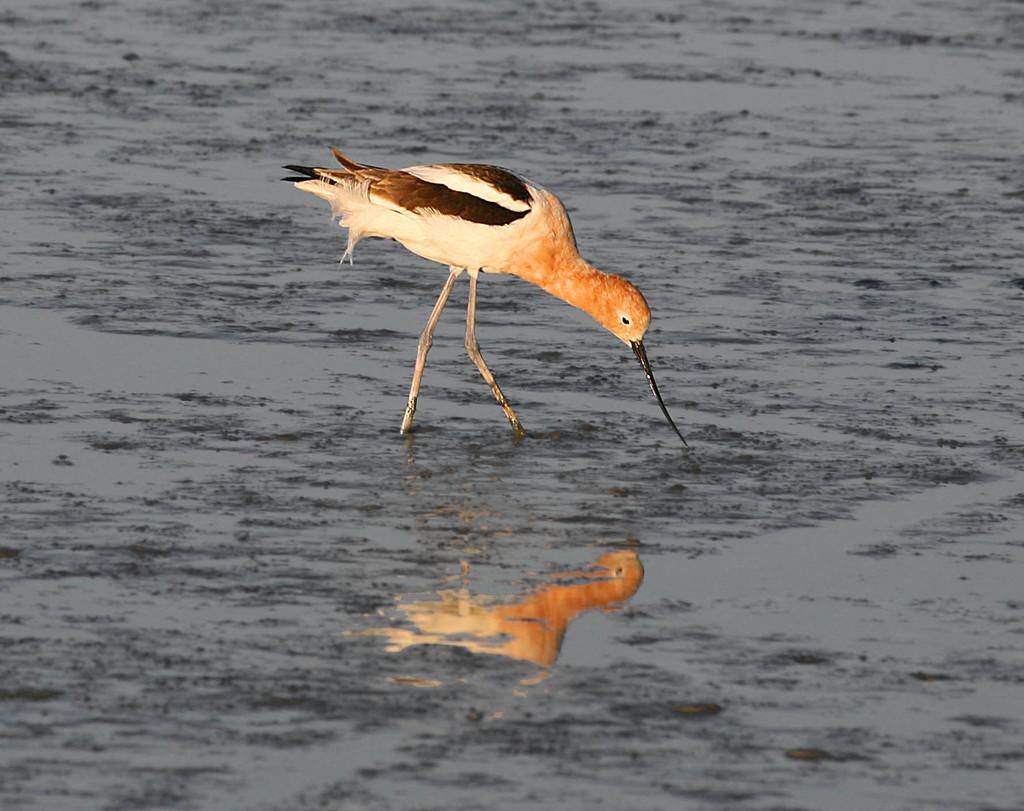What body of water is present in the image? There is a lake in the image. Are there any animals visible in the image? Yes, there is a bird on the lake. What type of destruction can be seen happening to the plants in the image? There are no plants present in the image, and therefore no destruction can be observed. 